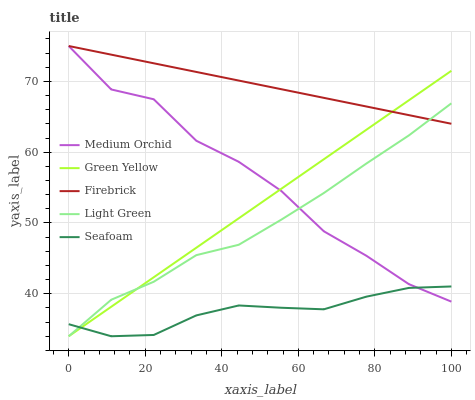Does Seafoam have the minimum area under the curve?
Answer yes or no. Yes. Does Firebrick have the maximum area under the curve?
Answer yes or no. Yes. Does Medium Orchid have the minimum area under the curve?
Answer yes or no. No. Does Medium Orchid have the maximum area under the curve?
Answer yes or no. No. Is Firebrick the smoothest?
Answer yes or no. Yes. Is Medium Orchid the roughest?
Answer yes or no. Yes. Is Medium Orchid the smoothest?
Answer yes or no. No. Is Firebrick the roughest?
Answer yes or no. No. Does Green Yellow have the lowest value?
Answer yes or no. Yes. Does Medium Orchid have the lowest value?
Answer yes or no. No. Does Firebrick have the highest value?
Answer yes or no. Yes. Does Light Green have the highest value?
Answer yes or no. No. Is Seafoam less than Firebrick?
Answer yes or no. Yes. Is Firebrick greater than Seafoam?
Answer yes or no. Yes. Does Green Yellow intersect Medium Orchid?
Answer yes or no. Yes. Is Green Yellow less than Medium Orchid?
Answer yes or no. No. Is Green Yellow greater than Medium Orchid?
Answer yes or no. No. Does Seafoam intersect Firebrick?
Answer yes or no. No. 